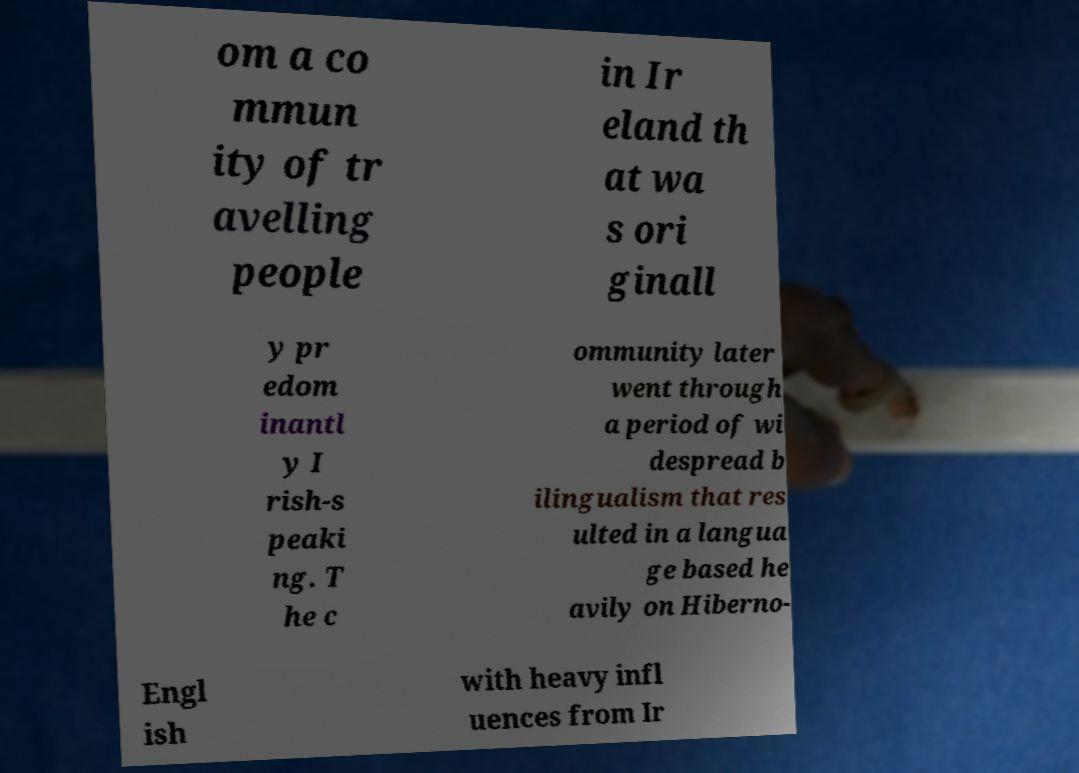There's text embedded in this image that I need extracted. Can you transcribe it verbatim? om a co mmun ity of tr avelling people in Ir eland th at wa s ori ginall y pr edom inantl y I rish-s peaki ng. T he c ommunity later went through a period of wi despread b ilingualism that res ulted in a langua ge based he avily on Hiberno- Engl ish with heavy infl uences from Ir 